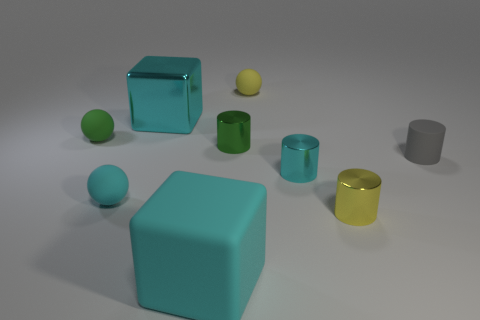What is the size of the matte cylinder?
Keep it short and to the point. Small. Do the big matte object and the big shiny object have the same color?
Offer a terse response. Yes. What number of objects are tiny green metal objects or yellow things that are behind the small rubber cylinder?
Provide a succinct answer. 2. How many small objects are to the right of the tiny yellow object that is behind the tiny rubber object that is on the left side of the cyan rubber sphere?
Your answer should be very brief. 3. There is a cylinder that is the same color as the big rubber thing; what is it made of?
Give a very brief answer. Metal. What number of tiny gray cylinders are there?
Your answer should be compact. 1. There is a yellow object on the right side of the yellow matte sphere; does it have the same size as the green metal cylinder?
Your answer should be compact. Yes. What number of metal things are green cylinders or tiny spheres?
Your response must be concise. 1. There is a small cyan thing that is to the left of the cyan metallic cylinder; what number of large rubber things are behind it?
Provide a short and direct response. 0. There is a matte object that is both behind the small gray object and on the left side of the small green shiny thing; what shape is it?
Your answer should be compact. Sphere. 